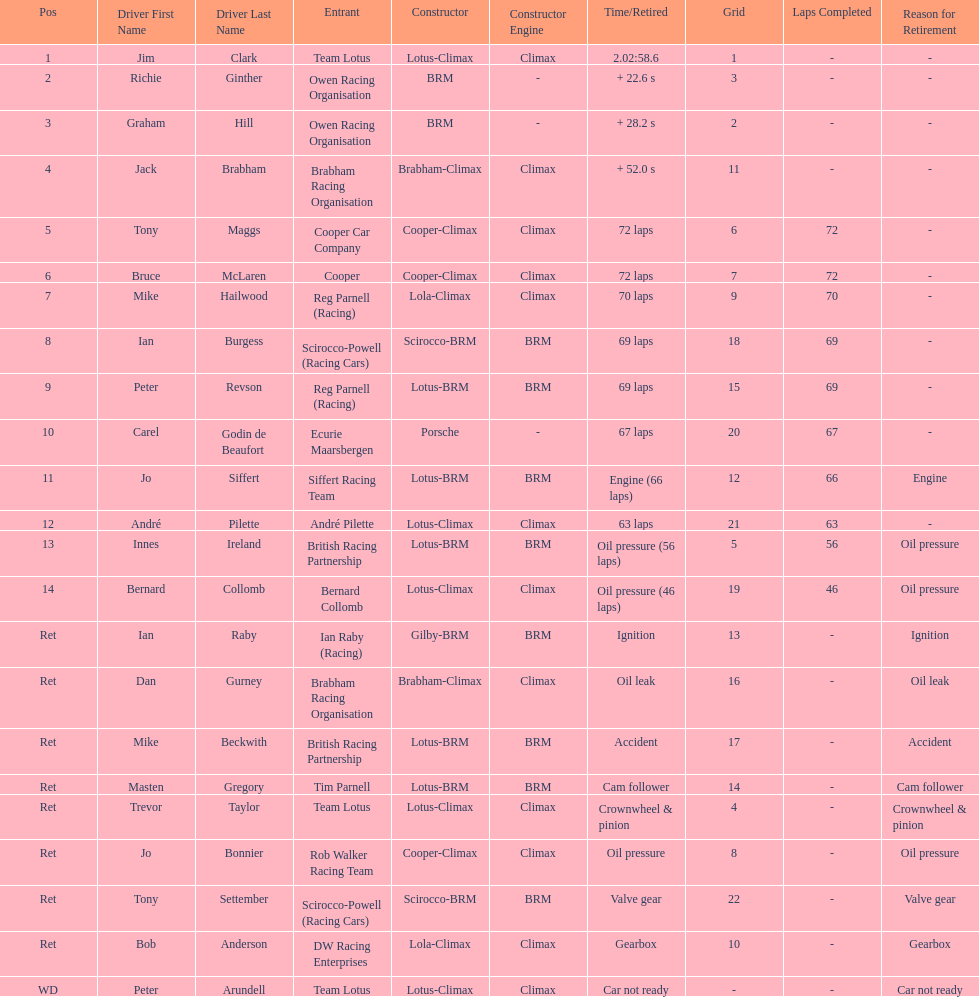What country had the least number of drivers, germany or the uk? Germany. 